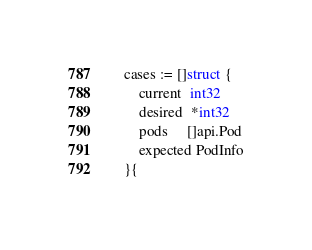<code> <loc_0><loc_0><loc_500><loc_500><_Go_>	cases := []struct {
		current  int32
		desired  *int32
		pods     []api.Pod
		expected PodInfo
	}{</code> 